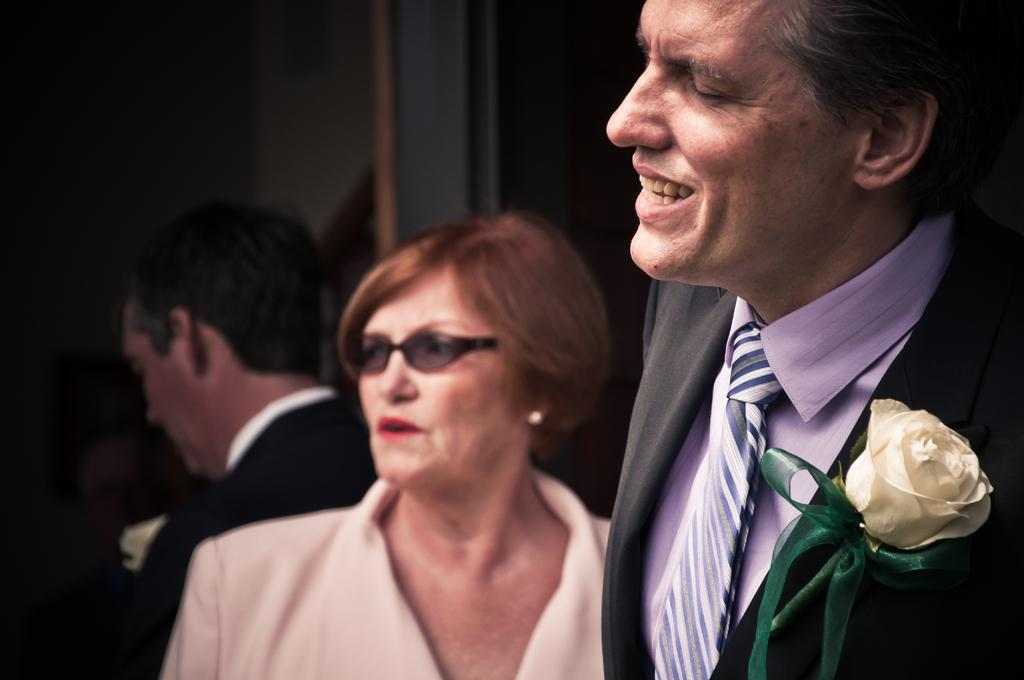What can be seen in the image related to people? There are persons wearing clothes in the image. What object is located in the bottom right of the image? There is a flower in the bottom right of the image. How would you describe the background of the image? The background of the image is blurred. What type of paper is being used to play volleyball in the image? There is no paper or volleyball present in the image. Can you describe the cushion that is being used by the persons in the image? There is no cushion mentioned or visible in the image. 